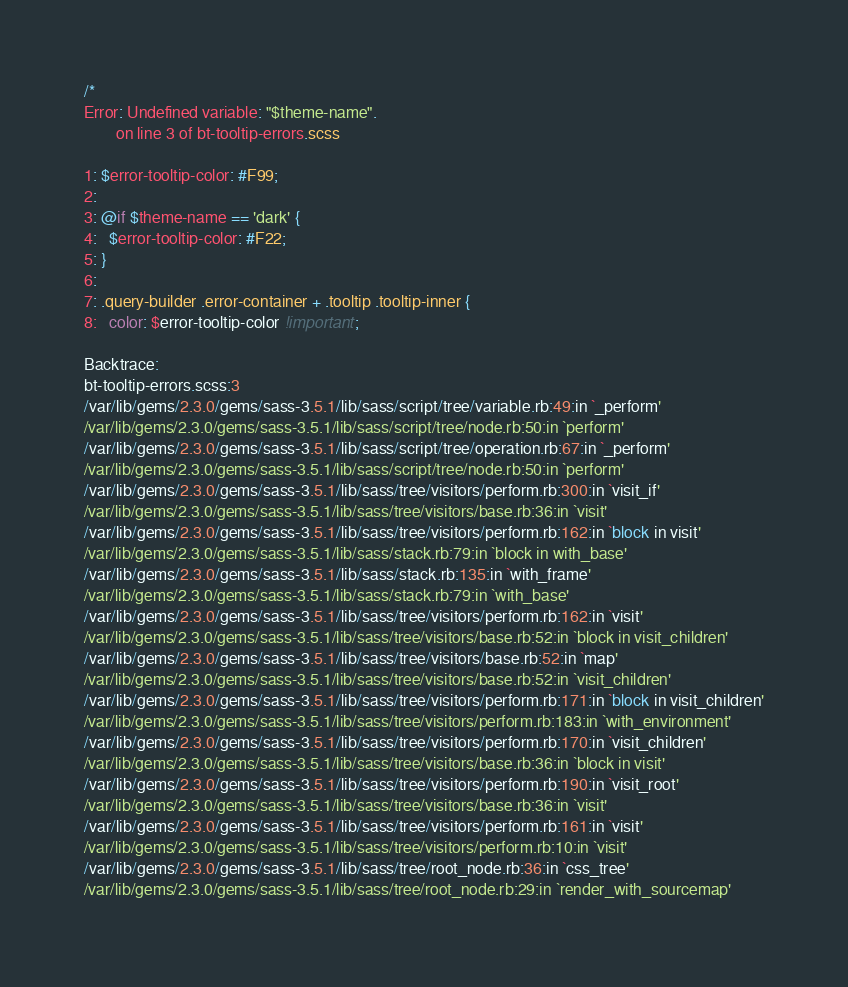<code> <loc_0><loc_0><loc_500><loc_500><_CSS_>/*
Error: Undefined variable: "$theme-name".
        on line 3 of bt-tooltip-errors.scss

1: $error-tooltip-color: #F99;
2: 
3: @if $theme-name == 'dark' {
4:   $error-tooltip-color: #F22;
5: }
6: 
7: .query-builder .error-container + .tooltip .tooltip-inner {
8:   color: $error-tooltip-color !important;

Backtrace:
bt-tooltip-errors.scss:3
/var/lib/gems/2.3.0/gems/sass-3.5.1/lib/sass/script/tree/variable.rb:49:in `_perform'
/var/lib/gems/2.3.0/gems/sass-3.5.1/lib/sass/script/tree/node.rb:50:in `perform'
/var/lib/gems/2.3.0/gems/sass-3.5.1/lib/sass/script/tree/operation.rb:67:in `_perform'
/var/lib/gems/2.3.0/gems/sass-3.5.1/lib/sass/script/tree/node.rb:50:in `perform'
/var/lib/gems/2.3.0/gems/sass-3.5.1/lib/sass/tree/visitors/perform.rb:300:in `visit_if'
/var/lib/gems/2.3.0/gems/sass-3.5.1/lib/sass/tree/visitors/base.rb:36:in `visit'
/var/lib/gems/2.3.0/gems/sass-3.5.1/lib/sass/tree/visitors/perform.rb:162:in `block in visit'
/var/lib/gems/2.3.0/gems/sass-3.5.1/lib/sass/stack.rb:79:in `block in with_base'
/var/lib/gems/2.3.0/gems/sass-3.5.1/lib/sass/stack.rb:135:in `with_frame'
/var/lib/gems/2.3.0/gems/sass-3.5.1/lib/sass/stack.rb:79:in `with_base'
/var/lib/gems/2.3.0/gems/sass-3.5.1/lib/sass/tree/visitors/perform.rb:162:in `visit'
/var/lib/gems/2.3.0/gems/sass-3.5.1/lib/sass/tree/visitors/base.rb:52:in `block in visit_children'
/var/lib/gems/2.3.0/gems/sass-3.5.1/lib/sass/tree/visitors/base.rb:52:in `map'
/var/lib/gems/2.3.0/gems/sass-3.5.1/lib/sass/tree/visitors/base.rb:52:in `visit_children'
/var/lib/gems/2.3.0/gems/sass-3.5.1/lib/sass/tree/visitors/perform.rb:171:in `block in visit_children'
/var/lib/gems/2.3.0/gems/sass-3.5.1/lib/sass/tree/visitors/perform.rb:183:in `with_environment'
/var/lib/gems/2.3.0/gems/sass-3.5.1/lib/sass/tree/visitors/perform.rb:170:in `visit_children'
/var/lib/gems/2.3.0/gems/sass-3.5.1/lib/sass/tree/visitors/base.rb:36:in `block in visit'
/var/lib/gems/2.3.0/gems/sass-3.5.1/lib/sass/tree/visitors/perform.rb:190:in `visit_root'
/var/lib/gems/2.3.0/gems/sass-3.5.1/lib/sass/tree/visitors/base.rb:36:in `visit'
/var/lib/gems/2.3.0/gems/sass-3.5.1/lib/sass/tree/visitors/perform.rb:161:in `visit'
/var/lib/gems/2.3.0/gems/sass-3.5.1/lib/sass/tree/visitors/perform.rb:10:in `visit'
/var/lib/gems/2.3.0/gems/sass-3.5.1/lib/sass/tree/root_node.rb:36:in `css_tree'
/var/lib/gems/2.3.0/gems/sass-3.5.1/lib/sass/tree/root_node.rb:29:in `render_with_sourcemap'</code> 